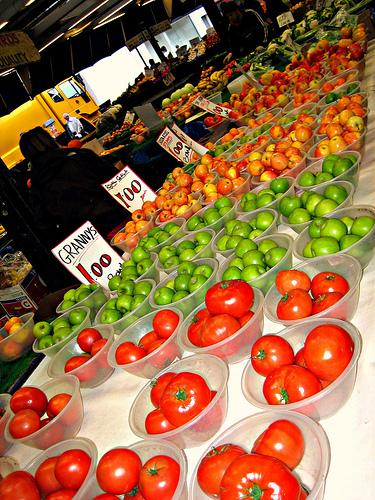In this image, what type of fruit do you see the most? Green apples and red tomatoes. What color is the delivery truck in the image? The delivery truck is yellow. Is there any price mentioned in the image for a type of fruit? Yes, Granny's 100 per pound is mentioned. What are the primary colors in the image? Green, red, and white. Identify the main object located at the center of the image. Several tomatoes in a clear basket. What are the emotions or atmosphere conveyed by the image? A bustling, lively atmosphere as people shop for fresh fruits and produce at a market. How would you describe the scene taking place in the image? A produce market with various fruits on display in clear bowls, a shopper browsing the selection, and a delivery truck in the background. What is the setting where the image takes place? A produce market with a long white table holding various fruits. Estimate how many different types of fruits are visible in the image. Four: Green apples, red apples, yellow apples, and red tomatoes. Describe an interaction happening between objects or people in the image. A customer shopping for produce is looking at the bowls of fruits on display. Point out the live band playing music on the sidewalk near the produce market. You should be able to see a guitarist, drummer, and vocalist performing in front of a small crowd. No, it's not mentioned in the image. 